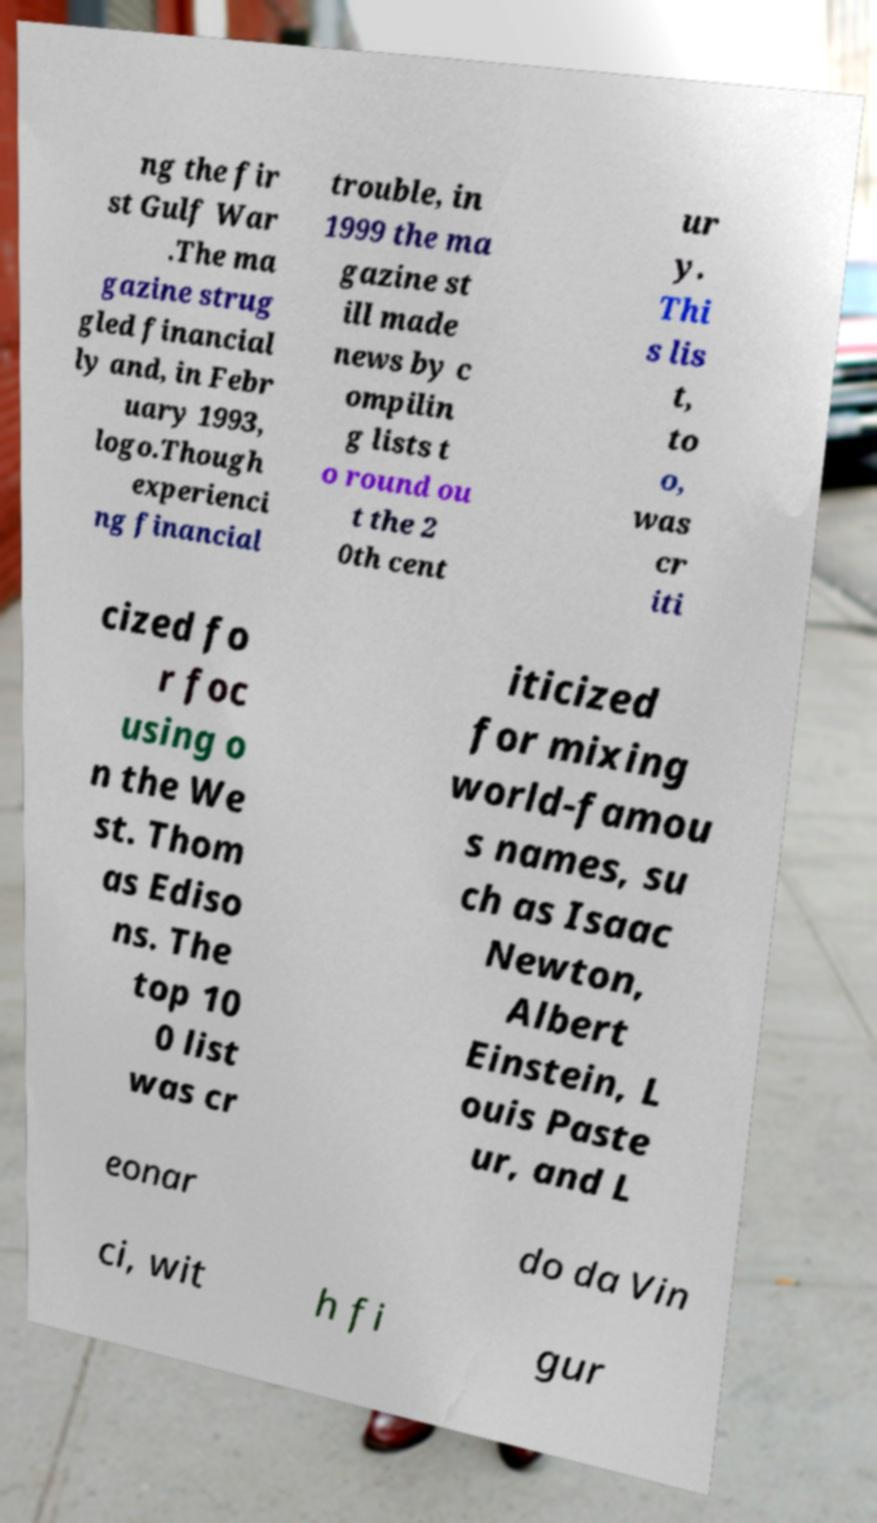Can you read and provide the text displayed in the image?This photo seems to have some interesting text. Can you extract and type it out for me? ng the fir st Gulf War .The ma gazine strug gled financial ly and, in Febr uary 1993, logo.Though experienci ng financial trouble, in 1999 the ma gazine st ill made news by c ompilin g lists t o round ou t the 2 0th cent ur y. Thi s lis t, to o, was cr iti cized fo r foc using o n the We st. Thom as Ediso ns. The top 10 0 list was cr iticized for mixing world-famou s names, su ch as Isaac Newton, Albert Einstein, L ouis Paste ur, and L eonar do da Vin ci, wit h fi gur 